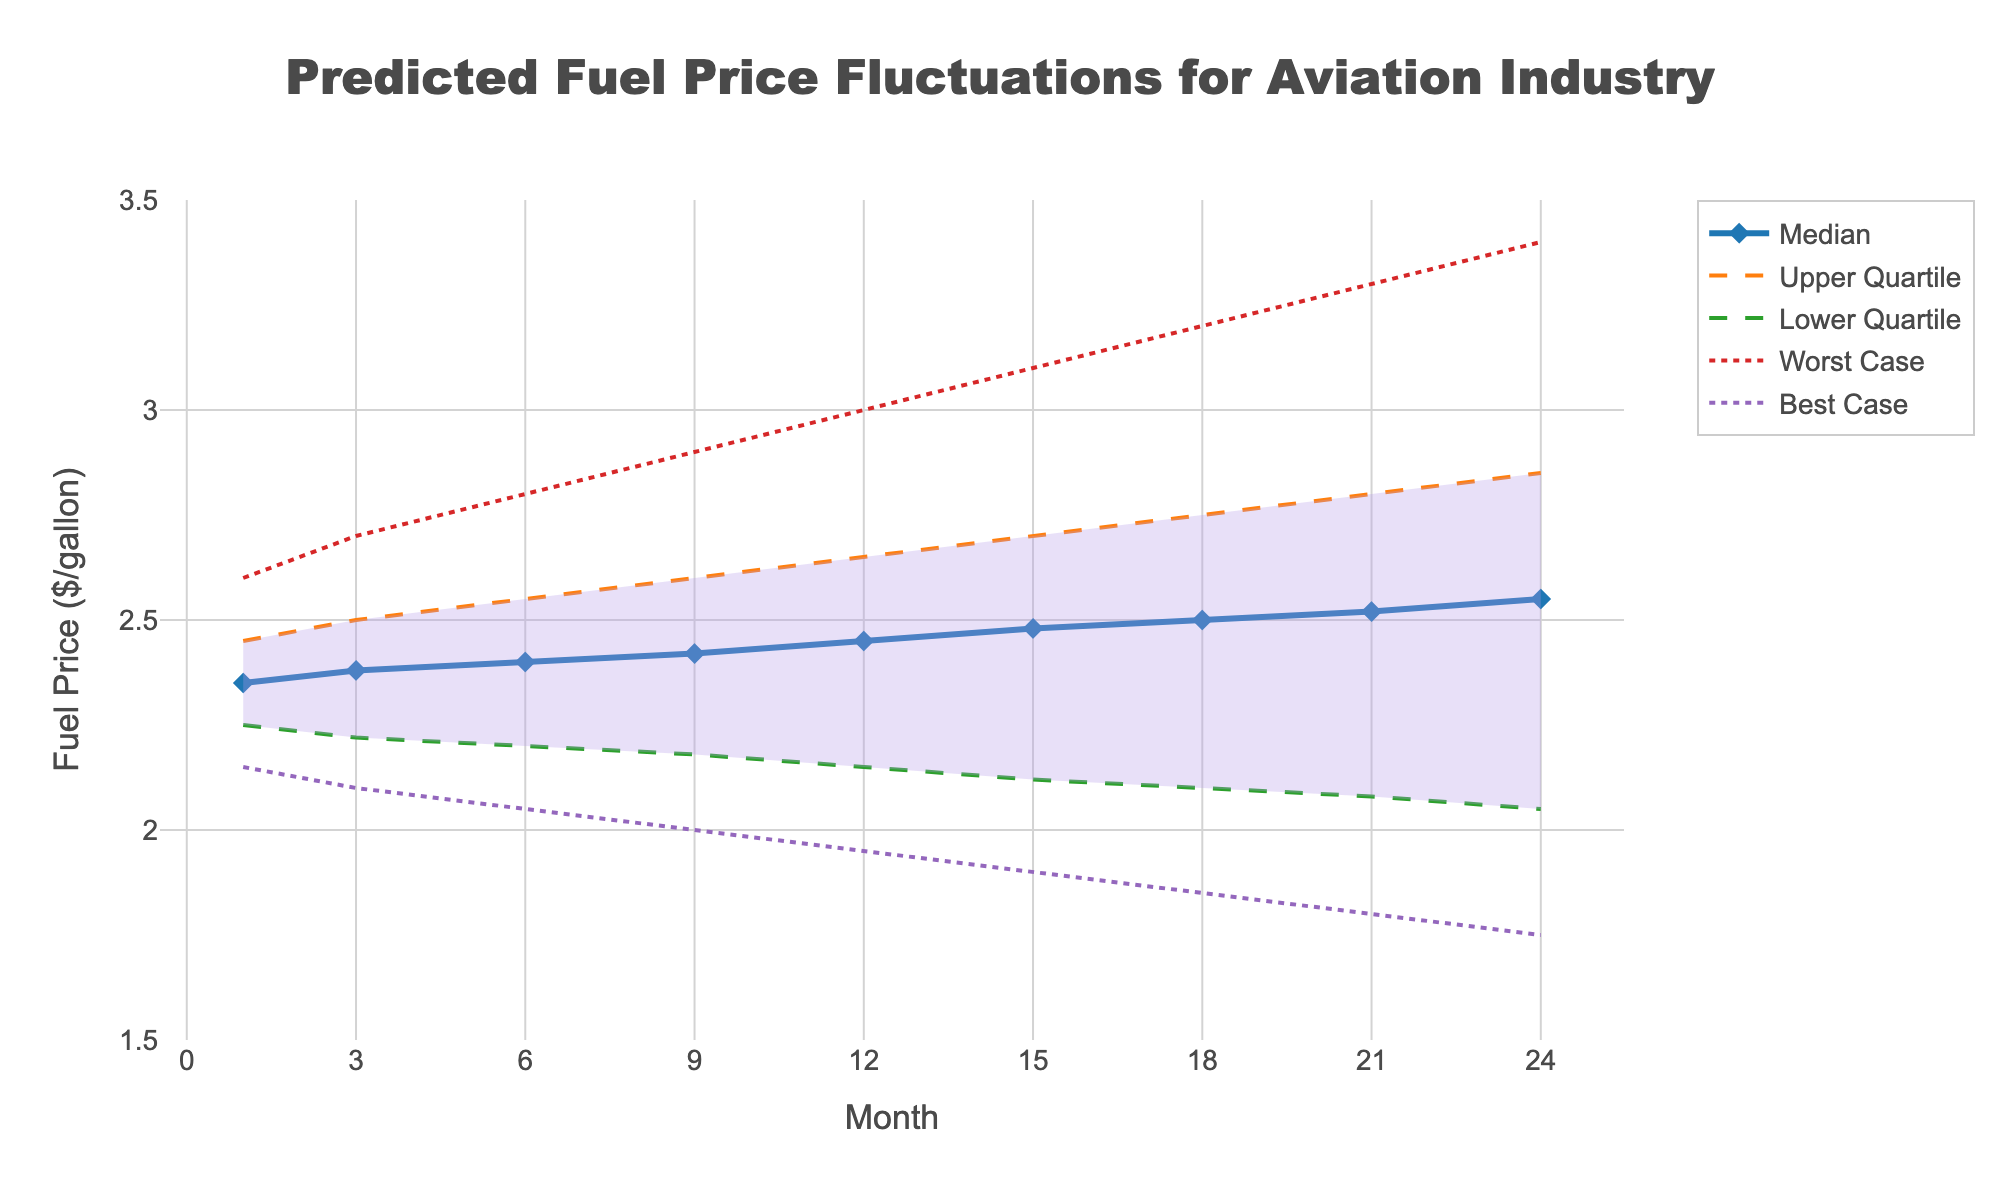What's the title of the figure? The title is normally found at the top of the figure and it is provided in a larger font size for visibility. Here, the title reads "Predicted Fuel Price Fluctuations for Aviation Industry".
Answer: Predicted Fuel Price Fluctuations for Aviation Industry What is the median fuel price predicted for month 12? Look at the median line (marked by diamonds) at the 12-month point. The value corresponding to this point on the y-axis can be read directly.
Answer: 2.45 How does the worst-case scenario fuel price change from month 1 to month 24? Identify the worst-case scenario line (dashed-dot line) and compare the values at month 1 and month 24. Subtract the month 1 value from the month 24 value to find the difference. The line moves from 2.60 to 3.40, the difference is 3.40 - 2.60.
Answer: 0.80 At what months do the median fuel prices cross the 2.50 mark? Observe the median line (blue solid line with diamonds) and identify the months where it crosses the 2.50 mark on the y-axis. The median line crosses 2.50 at months 18 and beyond.
Answer: 18, 21, 24 Which scenario shows the most significant price drop from month 1 to month 24? Compare the price changes from month 1 to month 24 for all scenarios. The best-case scenario line (purple dashed-dot line) drops from 2.15 to 1.75. This is the largest drop compared to other scenarios.
Answer: Best Case Between months 9 and 15, how does the interquartile range (IQR) change? IQR is calculated by subtracting the lower quartile from the upper quartile. Check values for months 9 and 15. For month 9: IQR = 2.60 - 2.18 = 0.42. For month 15: IQR = 2.70 - 2.12 = 0.58. Compare these values to see the change.
Answer: Increases What is the fuel price range (best to worst-case) for month 6? Look at the best-case and worst-case lines at month 6. The best-case price is 2.05, and the worst-case price is 2.80. Subtract the best-case value from the worst-case value to get the range: 2.80 - 2.05.
Answer: 0.75 What trend do you observe for the median fuel price over the 24 months? Follow the median line from month 1 to month 24. The median fuel price shows a gradual increase from 2.35 at month 1 to 2.55 at month 24.
Answer: Gradual Increase For month 24, how does the lower quartile forecast compare to the upper quartile forecast? Compare the lower quartile line (green dashed line) and the upper quartile line (orange dashed line) at month 24. The values are 2.05 (lower quartile) and 2.85 (upper quartile).
Answer: Lower 